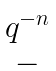<formula> <loc_0><loc_0><loc_500><loc_500>\begin{matrix} q ^ { - n } \\ - \end{matrix}</formula> 